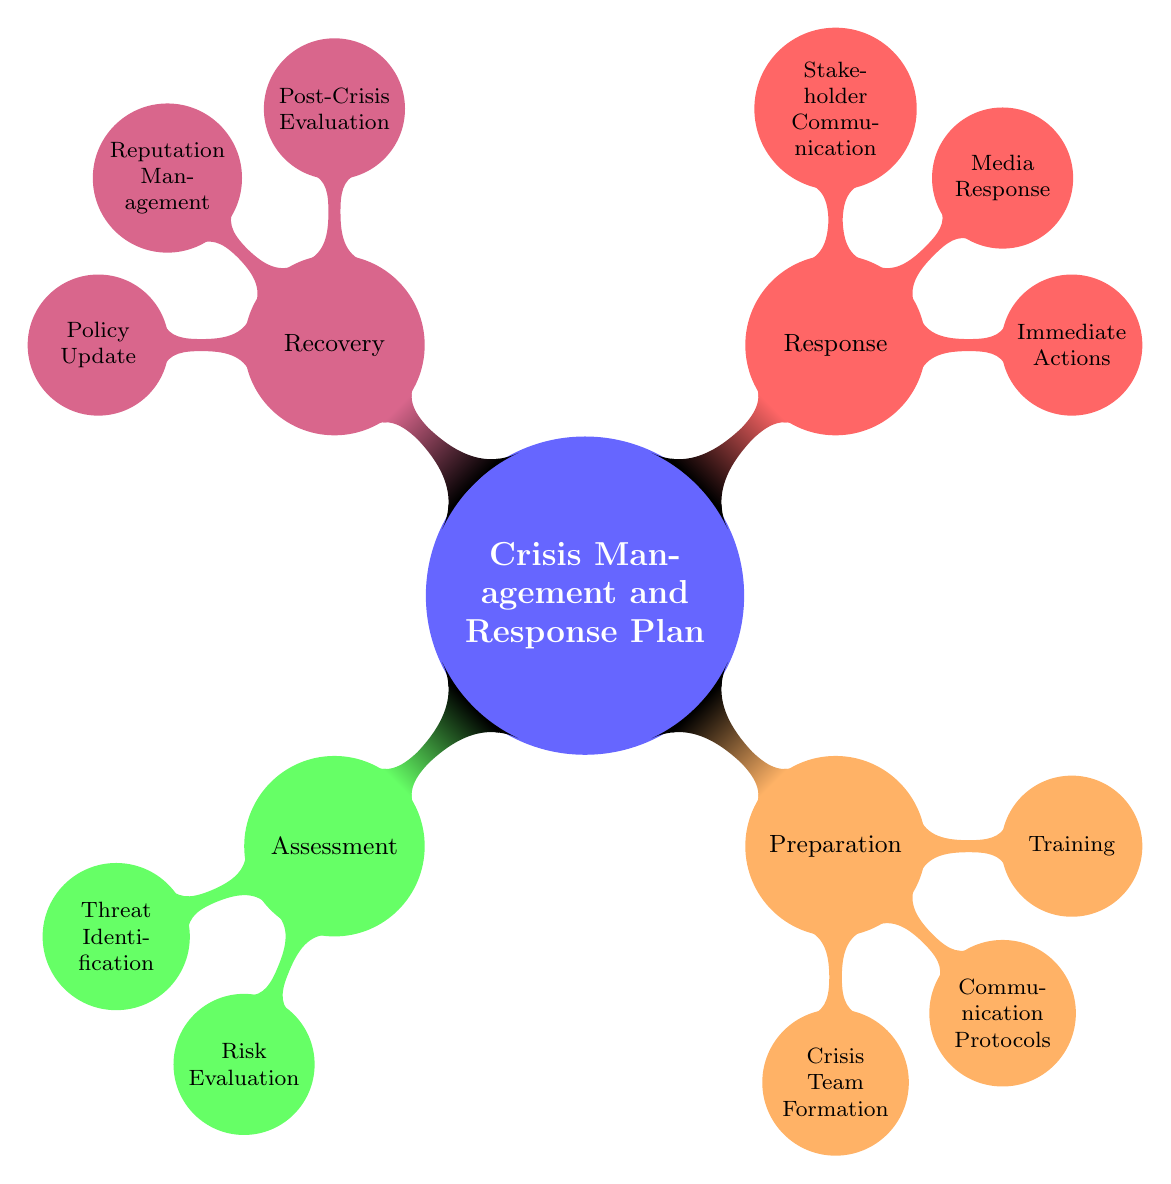What are the main components of the Crisis Management and Response Plan? The diagram identifies four main components: Assessment, Preparation, Response, and Recovery. Each of these components encompasses specific tasks or actions related to crisis management.
Answer: Assessment, Preparation, Response, Recovery How many nodes are in the 'Response' section? The 'Response' section consists of three nodes: Immediate Actions, Media Response, and Stakeholder Communication. Counting these nodes gives a total of three.
Answer: 3 What is the first action listed under the 'Preparation' category? The first action listed under the 'Preparation' category is 'Crisis Team Formation', which is the initial step in preparing for crisis management.
Answer: Crisis Team Formation What does 'Risk Evaluation' relate to? 'Risk Evaluation' is related to the process of assessing the likelihood and impact of identified threats, indicating its significance in the Assessment category.
Answer: Assessment Which category contains 'Post-Crisis Evaluation'? 'Post-Crisis Evaluation' is located within the 'Recovery' category, which focuses on evaluating responses and improving strategies after a crisis.
Answer: Recovery How many total actions are listed in the 'Preparation' section? The 'Preparation' section contains three specific actions: Crisis Team Formation, Communication Protocols, and Training. Adding these gives a total of three actions.
Answer: 3 What are the two components within the 'Assessment' cluster? The 'Assessment' cluster includes two components: Threat Identification and Risk Evaluation, both of which are essential for understanding potential crises.
Answer: Threat Identification, Risk Evaluation Which action follows 'Immediate Actions' in the 'Response' category? Following 'Immediate Actions' in the 'Response' category is 'Media Response', indicating what should happen after the initial actions are taken.
Answer: Media Response What action should be taken during the Recovery phase to enhance future crises management? The action to be taken during the Recovery phase for enhancing future crisis management is 'Policy Update', which involves revising crisis management policies based on learned lessons.
Answer: Policy Update 